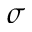Convert formula to latex. <formula><loc_0><loc_0><loc_500><loc_500>\sigma</formula> 